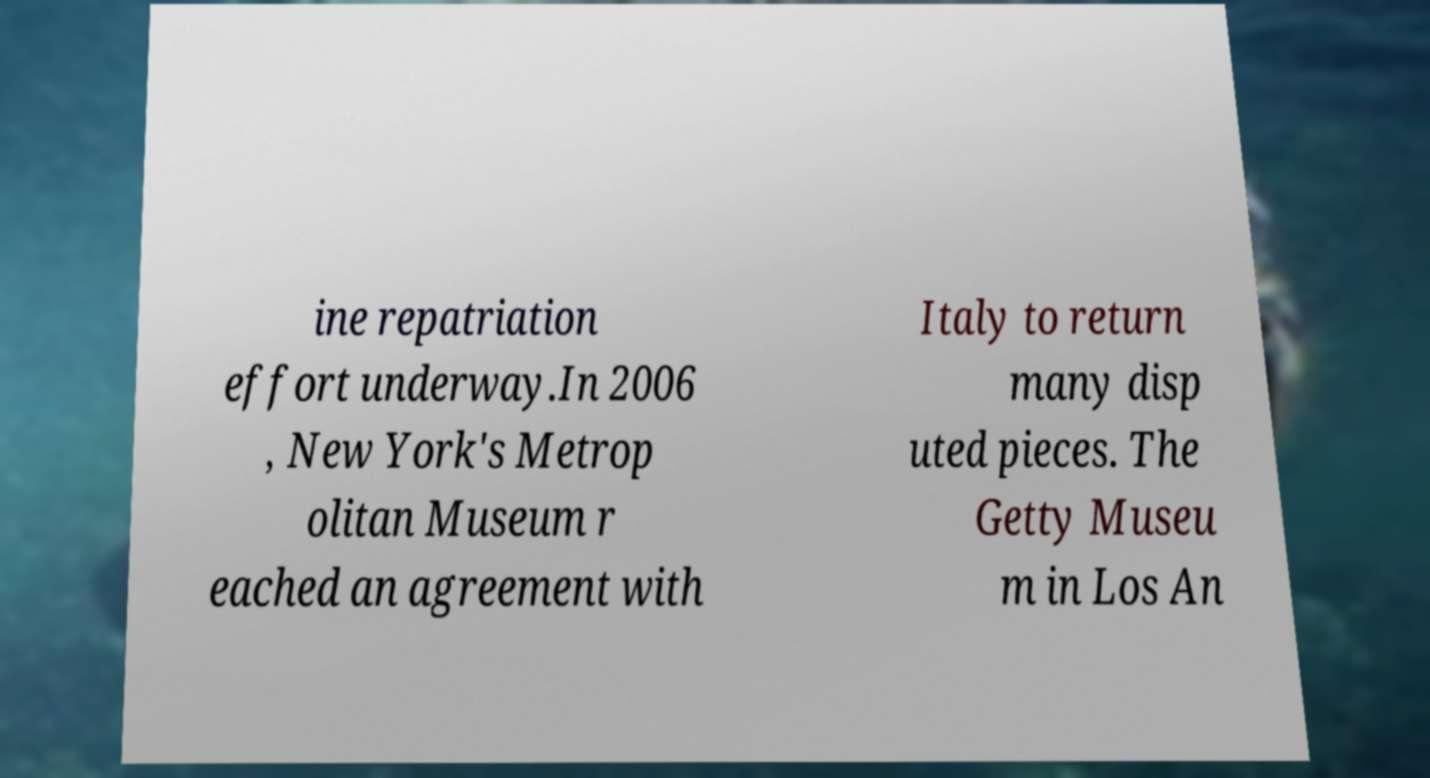Could you extract and type out the text from this image? ine repatriation effort underway.In 2006 , New York's Metrop olitan Museum r eached an agreement with Italy to return many disp uted pieces. The Getty Museu m in Los An 